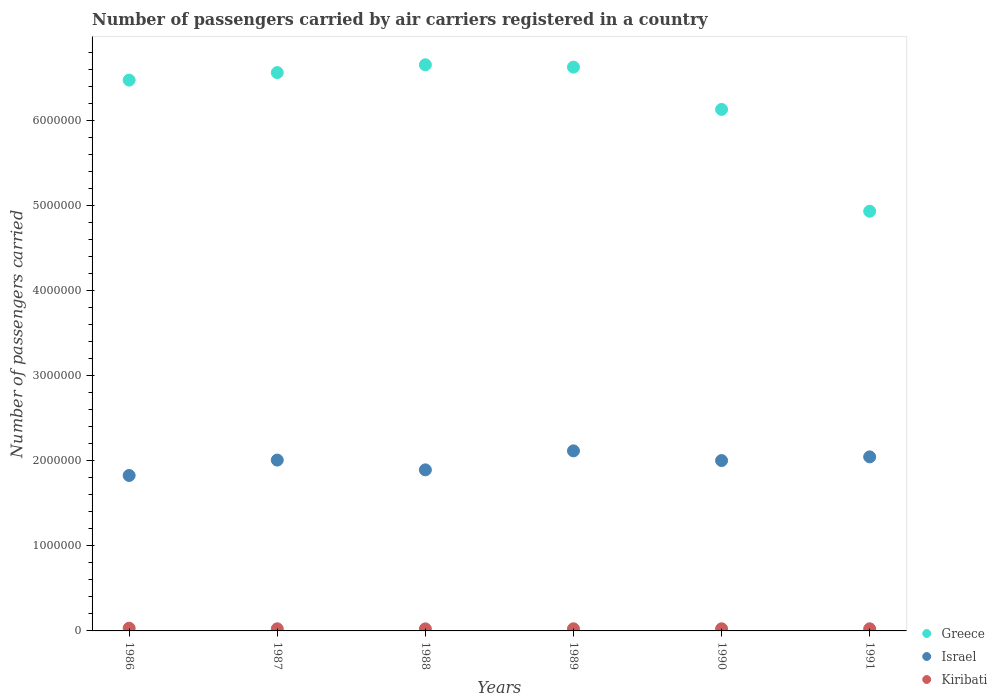How many different coloured dotlines are there?
Your response must be concise. 3. Is the number of dotlines equal to the number of legend labels?
Make the answer very short. Yes. What is the number of passengers carried by air carriers in Israel in 1987?
Give a very brief answer. 2.01e+06. Across all years, what is the maximum number of passengers carried by air carriers in Kiribati?
Your answer should be compact. 3.20e+04. Across all years, what is the minimum number of passengers carried by air carriers in Kiribati?
Make the answer very short. 2.40e+04. In which year was the number of passengers carried by air carriers in Kiribati maximum?
Make the answer very short. 1986. In which year was the number of passengers carried by air carriers in Israel minimum?
Your response must be concise. 1986. What is the total number of passengers carried by air carriers in Kiribati in the graph?
Your answer should be very brief. 1.56e+05. What is the difference between the number of passengers carried by air carriers in Israel in 1988 and that in 1989?
Offer a terse response. -2.23e+05. What is the difference between the number of passengers carried by air carriers in Greece in 1986 and the number of passengers carried by air carriers in Israel in 1987?
Provide a succinct answer. 4.47e+06. What is the average number of passengers carried by air carriers in Kiribati per year?
Offer a very short reply. 2.59e+04. In the year 1991, what is the difference between the number of passengers carried by air carriers in Kiribati and number of passengers carried by air carriers in Greece?
Give a very brief answer. -4.91e+06. In how many years, is the number of passengers carried by air carriers in Israel greater than 800000?
Make the answer very short. 6. Is the difference between the number of passengers carried by air carriers in Kiribati in 1986 and 1988 greater than the difference between the number of passengers carried by air carriers in Greece in 1986 and 1988?
Keep it short and to the point. Yes. What is the difference between the highest and the second highest number of passengers carried by air carriers in Greece?
Ensure brevity in your answer.  2.77e+04. What is the difference between the highest and the lowest number of passengers carried by air carriers in Israel?
Your answer should be compact. 2.89e+05. Does the number of passengers carried by air carriers in Israel monotonically increase over the years?
Provide a succinct answer. No. Is the number of passengers carried by air carriers in Israel strictly greater than the number of passengers carried by air carriers in Kiribati over the years?
Your response must be concise. Yes. Is the number of passengers carried by air carriers in Kiribati strictly less than the number of passengers carried by air carriers in Greece over the years?
Ensure brevity in your answer.  Yes. How many dotlines are there?
Provide a succinct answer. 3. Does the graph contain grids?
Keep it short and to the point. No. Where does the legend appear in the graph?
Offer a terse response. Bottom right. How many legend labels are there?
Ensure brevity in your answer.  3. What is the title of the graph?
Make the answer very short. Number of passengers carried by air carriers registered in a country. What is the label or title of the X-axis?
Give a very brief answer. Years. What is the label or title of the Y-axis?
Provide a short and direct response. Number of passengers carried. What is the Number of passengers carried of Greece in 1986?
Keep it short and to the point. 6.48e+06. What is the Number of passengers carried of Israel in 1986?
Ensure brevity in your answer.  1.83e+06. What is the Number of passengers carried of Kiribati in 1986?
Offer a terse response. 3.20e+04. What is the Number of passengers carried of Greece in 1987?
Keep it short and to the point. 6.57e+06. What is the Number of passengers carried in Israel in 1987?
Offer a terse response. 2.01e+06. What is the Number of passengers carried of Kiribati in 1987?
Provide a succinct answer. 2.49e+04. What is the Number of passengers carried in Greece in 1988?
Ensure brevity in your answer.  6.66e+06. What is the Number of passengers carried in Israel in 1988?
Ensure brevity in your answer.  1.89e+06. What is the Number of passengers carried of Kiribati in 1988?
Offer a terse response. 2.40e+04. What is the Number of passengers carried of Greece in 1989?
Your response must be concise. 6.63e+06. What is the Number of passengers carried in Israel in 1989?
Offer a terse response. 2.12e+06. What is the Number of passengers carried in Kiribati in 1989?
Your answer should be compact. 2.49e+04. What is the Number of passengers carried in Greece in 1990?
Your answer should be very brief. 6.13e+06. What is the Number of passengers carried of Israel in 1990?
Keep it short and to the point. 2.00e+06. What is the Number of passengers carried of Kiribati in 1990?
Provide a succinct answer. 2.49e+04. What is the Number of passengers carried in Greece in 1991?
Your answer should be very brief. 4.94e+06. What is the Number of passengers carried in Israel in 1991?
Provide a succinct answer. 2.05e+06. What is the Number of passengers carried of Kiribati in 1991?
Offer a very short reply. 2.49e+04. Across all years, what is the maximum Number of passengers carried of Greece?
Provide a short and direct response. 6.66e+06. Across all years, what is the maximum Number of passengers carried in Israel?
Keep it short and to the point. 2.12e+06. Across all years, what is the maximum Number of passengers carried of Kiribati?
Offer a very short reply. 3.20e+04. Across all years, what is the minimum Number of passengers carried in Greece?
Make the answer very short. 4.94e+06. Across all years, what is the minimum Number of passengers carried of Israel?
Give a very brief answer. 1.83e+06. Across all years, what is the minimum Number of passengers carried in Kiribati?
Provide a short and direct response. 2.40e+04. What is the total Number of passengers carried of Greece in the graph?
Your answer should be compact. 3.74e+07. What is the total Number of passengers carried in Israel in the graph?
Offer a terse response. 1.19e+07. What is the total Number of passengers carried of Kiribati in the graph?
Your response must be concise. 1.56e+05. What is the difference between the Number of passengers carried of Greece in 1986 and that in 1987?
Your answer should be very brief. -8.81e+04. What is the difference between the Number of passengers carried in Israel in 1986 and that in 1987?
Your response must be concise. -1.81e+05. What is the difference between the Number of passengers carried of Kiribati in 1986 and that in 1987?
Offer a very short reply. 7100. What is the difference between the Number of passengers carried in Greece in 1986 and that in 1988?
Your response must be concise. -1.80e+05. What is the difference between the Number of passengers carried in Israel in 1986 and that in 1988?
Ensure brevity in your answer.  -6.60e+04. What is the difference between the Number of passengers carried of Kiribati in 1986 and that in 1988?
Your answer should be very brief. 8000. What is the difference between the Number of passengers carried in Greece in 1986 and that in 1989?
Provide a short and direct response. -1.52e+05. What is the difference between the Number of passengers carried in Israel in 1986 and that in 1989?
Provide a short and direct response. -2.89e+05. What is the difference between the Number of passengers carried in Kiribati in 1986 and that in 1989?
Offer a very short reply. 7100. What is the difference between the Number of passengers carried of Greece in 1986 and that in 1990?
Ensure brevity in your answer.  3.45e+05. What is the difference between the Number of passengers carried in Israel in 1986 and that in 1990?
Give a very brief answer. -1.75e+05. What is the difference between the Number of passengers carried in Kiribati in 1986 and that in 1990?
Your answer should be very brief. 7100. What is the difference between the Number of passengers carried of Greece in 1986 and that in 1991?
Offer a very short reply. 1.54e+06. What is the difference between the Number of passengers carried in Israel in 1986 and that in 1991?
Keep it short and to the point. -2.19e+05. What is the difference between the Number of passengers carried of Kiribati in 1986 and that in 1991?
Keep it short and to the point. 7100. What is the difference between the Number of passengers carried of Greece in 1987 and that in 1988?
Your answer should be very brief. -9.21e+04. What is the difference between the Number of passengers carried of Israel in 1987 and that in 1988?
Ensure brevity in your answer.  1.15e+05. What is the difference between the Number of passengers carried in Kiribati in 1987 and that in 1988?
Ensure brevity in your answer.  900. What is the difference between the Number of passengers carried in Greece in 1987 and that in 1989?
Keep it short and to the point. -6.44e+04. What is the difference between the Number of passengers carried of Israel in 1987 and that in 1989?
Offer a terse response. -1.08e+05. What is the difference between the Number of passengers carried in Kiribati in 1987 and that in 1989?
Your answer should be compact. 0. What is the difference between the Number of passengers carried in Greece in 1987 and that in 1990?
Your response must be concise. 4.33e+05. What is the difference between the Number of passengers carried of Israel in 1987 and that in 1990?
Your response must be concise. 5700. What is the difference between the Number of passengers carried of Kiribati in 1987 and that in 1990?
Ensure brevity in your answer.  0. What is the difference between the Number of passengers carried of Greece in 1987 and that in 1991?
Your response must be concise. 1.63e+06. What is the difference between the Number of passengers carried in Israel in 1987 and that in 1991?
Offer a terse response. -3.78e+04. What is the difference between the Number of passengers carried of Kiribati in 1987 and that in 1991?
Ensure brevity in your answer.  0. What is the difference between the Number of passengers carried of Greece in 1988 and that in 1989?
Your response must be concise. 2.77e+04. What is the difference between the Number of passengers carried of Israel in 1988 and that in 1989?
Offer a very short reply. -2.23e+05. What is the difference between the Number of passengers carried of Kiribati in 1988 and that in 1989?
Offer a very short reply. -900. What is the difference between the Number of passengers carried in Greece in 1988 and that in 1990?
Keep it short and to the point. 5.25e+05. What is the difference between the Number of passengers carried in Israel in 1988 and that in 1990?
Make the answer very short. -1.09e+05. What is the difference between the Number of passengers carried of Kiribati in 1988 and that in 1990?
Make the answer very short. -900. What is the difference between the Number of passengers carried in Greece in 1988 and that in 1991?
Provide a succinct answer. 1.72e+06. What is the difference between the Number of passengers carried in Israel in 1988 and that in 1991?
Offer a terse response. -1.53e+05. What is the difference between the Number of passengers carried of Kiribati in 1988 and that in 1991?
Your response must be concise. -900. What is the difference between the Number of passengers carried of Greece in 1989 and that in 1990?
Make the answer very short. 4.97e+05. What is the difference between the Number of passengers carried in Israel in 1989 and that in 1990?
Provide a succinct answer. 1.14e+05. What is the difference between the Number of passengers carried of Greece in 1989 and that in 1991?
Offer a terse response. 1.70e+06. What is the difference between the Number of passengers carried in Israel in 1989 and that in 1991?
Offer a terse response. 7.05e+04. What is the difference between the Number of passengers carried in Greece in 1990 and that in 1991?
Give a very brief answer. 1.20e+06. What is the difference between the Number of passengers carried of Israel in 1990 and that in 1991?
Ensure brevity in your answer.  -4.35e+04. What is the difference between the Number of passengers carried in Kiribati in 1990 and that in 1991?
Ensure brevity in your answer.  0. What is the difference between the Number of passengers carried of Greece in 1986 and the Number of passengers carried of Israel in 1987?
Keep it short and to the point. 4.47e+06. What is the difference between the Number of passengers carried of Greece in 1986 and the Number of passengers carried of Kiribati in 1987?
Provide a succinct answer. 6.45e+06. What is the difference between the Number of passengers carried of Israel in 1986 and the Number of passengers carried of Kiribati in 1987?
Make the answer very short. 1.80e+06. What is the difference between the Number of passengers carried in Greece in 1986 and the Number of passengers carried in Israel in 1988?
Ensure brevity in your answer.  4.58e+06. What is the difference between the Number of passengers carried in Greece in 1986 and the Number of passengers carried in Kiribati in 1988?
Keep it short and to the point. 6.46e+06. What is the difference between the Number of passengers carried in Israel in 1986 and the Number of passengers carried in Kiribati in 1988?
Provide a succinct answer. 1.80e+06. What is the difference between the Number of passengers carried of Greece in 1986 and the Number of passengers carried of Israel in 1989?
Your answer should be very brief. 4.36e+06. What is the difference between the Number of passengers carried of Greece in 1986 and the Number of passengers carried of Kiribati in 1989?
Make the answer very short. 6.45e+06. What is the difference between the Number of passengers carried in Israel in 1986 and the Number of passengers carried in Kiribati in 1989?
Keep it short and to the point. 1.80e+06. What is the difference between the Number of passengers carried in Greece in 1986 and the Number of passengers carried in Israel in 1990?
Give a very brief answer. 4.48e+06. What is the difference between the Number of passengers carried of Greece in 1986 and the Number of passengers carried of Kiribati in 1990?
Give a very brief answer. 6.45e+06. What is the difference between the Number of passengers carried in Israel in 1986 and the Number of passengers carried in Kiribati in 1990?
Make the answer very short. 1.80e+06. What is the difference between the Number of passengers carried in Greece in 1986 and the Number of passengers carried in Israel in 1991?
Offer a terse response. 4.43e+06. What is the difference between the Number of passengers carried of Greece in 1986 and the Number of passengers carried of Kiribati in 1991?
Your answer should be compact. 6.45e+06. What is the difference between the Number of passengers carried in Israel in 1986 and the Number of passengers carried in Kiribati in 1991?
Offer a terse response. 1.80e+06. What is the difference between the Number of passengers carried of Greece in 1987 and the Number of passengers carried of Israel in 1988?
Offer a very short reply. 4.67e+06. What is the difference between the Number of passengers carried in Greece in 1987 and the Number of passengers carried in Kiribati in 1988?
Offer a terse response. 6.54e+06. What is the difference between the Number of passengers carried of Israel in 1987 and the Number of passengers carried of Kiribati in 1988?
Offer a very short reply. 1.99e+06. What is the difference between the Number of passengers carried in Greece in 1987 and the Number of passengers carried in Israel in 1989?
Offer a very short reply. 4.45e+06. What is the difference between the Number of passengers carried of Greece in 1987 and the Number of passengers carried of Kiribati in 1989?
Your answer should be compact. 6.54e+06. What is the difference between the Number of passengers carried in Israel in 1987 and the Number of passengers carried in Kiribati in 1989?
Keep it short and to the point. 1.98e+06. What is the difference between the Number of passengers carried of Greece in 1987 and the Number of passengers carried of Israel in 1990?
Your answer should be very brief. 4.56e+06. What is the difference between the Number of passengers carried in Greece in 1987 and the Number of passengers carried in Kiribati in 1990?
Your response must be concise. 6.54e+06. What is the difference between the Number of passengers carried in Israel in 1987 and the Number of passengers carried in Kiribati in 1990?
Ensure brevity in your answer.  1.98e+06. What is the difference between the Number of passengers carried in Greece in 1987 and the Number of passengers carried in Israel in 1991?
Your response must be concise. 4.52e+06. What is the difference between the Number of passengers carried of Greece in 1987 and the Number of passengers carried of Kiribati in 1991?
Offer a terse response. 6.54e+06. What is the difference between the Number of passengers carried in Israel in 1987 and the Number of passengers carried in Kiribati in 1991?
Offer a very short reply. 1.98e+06. What is the difference between the Number of passengers carried in Greece in 1988 and the Number of passengers carried in Israel in 1989?
Keep it short and to the point. 4.54e+06. What is the difference between the Number of passengers carried of Greece in 1988 and the Number of passengers carried of Kiribati in 1989?
Ensure brevity in your answer.  6.63e+06. What is the difference between the Number of passengers carried in Israel in 1988 and the Number of passengers carried in Kiribati in 1989?
Give a very brief answer. 1.87e+06. What is the difference between the Number of passengers carried in Greece in 1988 and the Number of passengers carried in Israel in 1990?
Make the answer very short. 4.66e+06. What is the difference between the Number of passengers carried in Greece in 1988 and the Number of passengers carried in Kiribati in 1990?
Provide a short and direct response. 6.63e+06. What is the difference between the Number of passengers carried in Israel in 1988 and the Number of passengers carried in Kiribati in 1990?
Provide a short and direct response. 1.87e+06. What is the difference between the Number of passengers carried in Greece in 1988 and the Number of passengers carried in Israel in 1991?
Ensure brevity in your answer.  4.61e+06. What is the difference between the Number of passengers carried in Greece in 1988 and the Number of passengers carried in Kiribati in 1991?
Give a very brief answer. 6.63e+06. What is the difference between the Number of passengers carried of Israel in 1988 and the Number of passengers carried of Kiribati in 1991?
Give a very brief answer. 1.87e+06. What is the difference between the Number of passengers carried in Greece in 1989 and the Number of passengers carried in Israel in 1990?
Give a very brief answer. 4.63e+06. What is the difference between the Number of passengers carried of Greece in 1989 and the Number of passengers carried of Kiribati in 1990?
Your response must be concise. 6.61e+06. What is the difference between the Number of passengers carried in Israel in 1989 and the Number of passengers carried in Kiribati in 1990?
Your response must be concise. 2.09e+06. What is the difference between the Number of passengers carried of Greece in 1989 and the Number of passengers carried of Israel in 1991?
Make the answer very short. 4.58e+06. What is the difference between the Number of passengers carried in Greece in 1989 and the Number of passengers carried in Kiribati in 1991?
Provide a succinct answer. 6.61e+06. What is the difference between the Number of passengers carried in Israel in 1989 and the Number of passengers carried in Kiribati in 1991?
Make the answer very short. 2.09e+06. What is the difference between the Number of passengers carried in Greece in 1990 and the Number of passengers carried in Israel in 1991?
Your response must be concise. 4.09e+06. What is the difference between the Number of passengers carried in Greece in 1990 and the Number of passengers carried in Kiribati in 1991?
Make the answer very short. 6.11e+06. What is the difference between the Number of passengers carried of Israel in 1990 and the Number of passengers carried of Kiribati in 1991?
Offer a very short reply. 1.98e+06. What is the average Number of passengers carried in Greece per year?
Provide a succinct answer. 6.24e+06. What is the average Number of passengers carried in Israel per year?
Give a very brief answer. 1.98e+06. What is the average Number of passengers carried of Kiribati per year?
Give a very brief answer. 2.59e+04. In the year 1986, what is the difference between the Number of passengers carried in Greece and Number of passengers carried in Israel?
Your response must be concise. 4.65e+06. In the year 1986, what is the difference between the Number of passengers carried in Greece and Number of passengers carried in Kiribati?
Ensure brevity in your answer.  6.45e+06. In the year 1986, what is the difference between the Number of passengers carried in Israel and Number of passengers carried in Kiribati?
Your response must be concise. 1.80e+06. In the year 1987, what is the difference between the Number of passengers carried in Greece and Number of passengers carried in Israel?
Keep it short and to the point. 4.56e+06. In the year 1987, what is the difference between the Number of passengers carried of Greece and Number of passengers carried of Kiribati?
Provide a succinct answer. 6.54e+06. In the year 1987, what is the difference between the Number of passengers carried in Israel and Number of passengers carried in Kiribati?
Keep it short and to the point. 1.98e+06. In the year 1988, what is the difference between the Number of passengers carried of Greece and Number of passengers carried of Israel?
Your response must be concise. 4.77e+06. In the year 1988, what is the difference between the Number of passengers carried of Greece and Number of passengers carried of Kiribati?
Provide a succinct answer. 6.64e+06. In the year 1988, what is the difference between the Number of passengers carried of Israel and Number of passengers carried of Kiribati?
Keep it short and to the point. 1.87e+06. In the year 1989, what is the difference between the Number of passengers carried of Greece and Number of passengers carried of Israel?
Offer a terse response. 4.51e+06. In the year 1989, what is the difference between the Number of passengers carried in Greece and Number of passengers carried in Kiribati?
Give a very brief answer. 6.61e+06. In the year 1989, what is the difference between the Number of passengers carried in Israel and Number of passengers carried in Kiribati?
Your answer should be compact. 2.09e+06. In the year 1990, what is the difference between the Number of passengers carried in Greece and Number of passengers carried in Israel?
Keep it short and to the point. 4.13e+06. In the year 1990, what is the difference between the Number of passengers carried in Greece and Number of passengers carried in Kiribati?
Keep it short and to the point. 6.11e+06. In the year 1990, what is the difference between the Number of passengers carried of Israel and Number of passengers carried of Kiribati?
Give a very brief answer. 1.98e+06. In the year 1991, what is the difference between the Number of passengers carried in Greece and Number of passengers carried in Israel?
Make the answer very short. 2.89e+06. In the year 1991, what is the difference between the Number of passengers carried in Greece and Number of passengers carried in Kiribati?
Ensure brevity in your answer.  4.91e+06. In the year 1991, what is the difference between the Number of passengers carried of Israel and Number of passengers carried of Kiribati?
Provide a short and direct response. 2.02e+06. What is the ratio of the Number of passengers carried in Greece in 1986 to that in 1987?
Provide a succinct answer. 0.99. What is the ratio of the Number of passengers carried in Israel in 1986 to that in 1987?
Ensure brevity in your answer.  0.91. What is the ratio of the Number of passengers carried in Kiribati in 1986 to that in 1987?
Provide a short and direct response. 1.29. What is the ratio of the Number of passengers carried in Greece in 1986 to that in 1988?
Keep it short and to the point. 0.97. What is the ratio of the Number of passengers carried in Israel in 1986 to that in 1988?
Provide a short and direct response. 0.97. What is the ratio of the Number of passengers carried of Israel in 1986 to that in 1989?
Keep it short and to the point. 0.86. What is the ratio of the Number of passengers carried in Kiribati in 1986 to that in 1989?
Keep it short and to the point. 1.29. What is the ratio of the Number of passengers carried in Greece in 1986 to that in 1990?
Make the answer very short. 1.06. What is the ratio of the Number of passengers carried of Israel in 1986 to that in 1990?
Ensure brevity in your answer.  0.91. What is the ratio of the Number of passengers carried in Kiribati in 1986 to that in 1990?
Your response must be concise. 1.29. What is the ratio of the Number of passengers carried of Greece in 1986 to that in 1991?
Provide a succinct answer. 1.31. What is the ratio of the Number of passengers carried in Israel in 1986 to that in 1991?
Provide a short and direct response. 0.89. What is the ratio of the Number of passengers carried in Kiribati in 1986 to that in 1991?
Offer a terse response. 1.29. What is the ratio of the Number of passengers carried in Greece in 1987 to that in 1988?
Offer a very short reply. 0.99. What is the ratio of the Number of passengers carried of Israel in 1987 to that in 1988?
Offer a terse response. 1.06. What is the ratio of the Number of passengers carried of Kiribati in 1987 to that in 1988?
Your answer should be compact. 1.04. What is the ratio of the Number of passengers carried in Greece in 1987 to that in 1989?
Ensure brevity in your answer.  0.99. What is the ratio of the Number of passengers carried of Israel in 1987 to that in 1989?
Give a very brief answer. 0.95. What is the ratio of the Number of passengers carried of Kiribati in 1987 to that in 1989?
Provide a short and direct response. 1. What is the ratio of the Number of passengers carried of Greece in 1987 to that in 1990?
Offer a terse response. 1.07. What is the ratio of the Number of passengers carried of Greece in 1987 to that in 1991?
Provide a short and direct response. 1.33. What is the ratio of the Number of passengers carried of Israel in 1987 to that in 1991?
Provide a succinct answer. 0.98. What is the ratio of the Number of passengers carried of Greece in 1988 to that in 1989?
Your answer should be compact. 1. What is the ratio of the Number of passengers carried in Israel in 1988 to that in 1989?
Offer a terse response. 0.89. What is the ratio of the Number of passengers carried in Kiribati in 1988 to that in 1989?
Keep it short and to the point. 0.96. What is the ratio of the Number of passengers carried of Greece in 1988 to that in 1990?
Offer a very short reply. 1.09. What is the ratio of the Number of passengers carried in Israel in 1988 to that in 1990?
Provide a short and direct response. 0.95. What is the ratio of the Number of passengers carried in Kiribati in 1988 to that in 1990?
Your response must be concise. 0.96. What is the ratio of the Number of passengers carried of Greece in 1988 to that in 1991?
Offer a terse response. 1.35. What is the ratio of the Number of passengers carried of Israel in 1988 to that in 1991?
Your answer should be compact. 0.93. What is the ratio of the Number of passengers carried in Kiribati in 1988 to that in 1991?
Offer a terse response. 0.96. What is the ratio of the Number of passengers carried of Greece in 1989 to that in 1990?
Your answer should be compact. 1.08. What is the ratio of the Number of passengers carried in Israel in 1989 to that in 1990?
Your answer should be very brief. 1.06. What is the ratio of the Number of passengers carried in Kiribati in 1989 to that in 1990?
Ensure brevity in your answer.  1. What is the ratio of the Number of passengers carried of Greece in 1989 to that in 1991?
Make the answer very short. 1.34. What is the ratio of the Number of passengers carried of Israel in 1989 to that in 1991?
Offer a terse response. 1.03. What is the ratio of the Number of passengers carried in Greece in 1990 to that in 1991?
Your answer should be very brief. 1.24. What is the ratio of the Number of passengers carried in Israel in 1990 to that in 1991?
Your answer should be very brief. 0.98. What is the ratio of the Number of passengers carried of Kiribati in 1990 to that in 1991?
Offer a terse response. 1. What is the difference between the highest and the second highest Number of passengers carried of Greece?
Give a very brief answer. 2.77e+04. What is the difference between the highest and the second highest Number of passengers carried in Israel?
Offer a very short reply. 7.05e+04. What is the difference between the highest and the second highest Number of passengers carried in Kiribati?
Keep it short and to the point. 7100. What is the difference between the highest and the lowest Number of passengers carried in Greece?
Your answer should be very brief. 1.72e+06. What is the difference between the highest and the lowest Number of passengers carried in Israel?
Provide a succinct answer. 2.89e+05. What is the difference between the highest and the lowest Number of passengers carried of Kiribati?
Offer a terse response. 8000. 